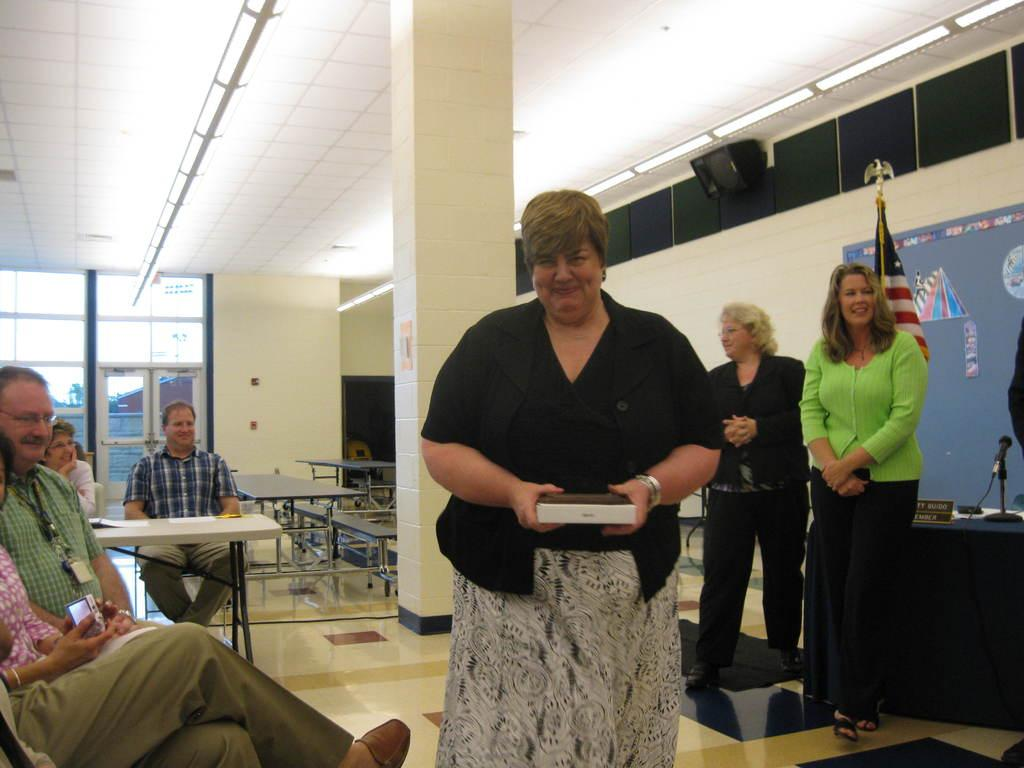What type of structure can be seen in the image? There is a wall in the image. Is there any entrance visible in the image? Yes, there is a door in the image. What are the people in the image doing? The people in the image are standing and sitting. What can be seen flying in the image? There is a flag in the image. What type of seating is available in the image? There are benches in the image. What type of war is being fought in the image? There is no war depicted in the image; it features a wall, a door, people, a flag, and benches. What record is being set by the dinosaurs in the image? There are no dinosaurs present in the image, so no record can be set by them. 